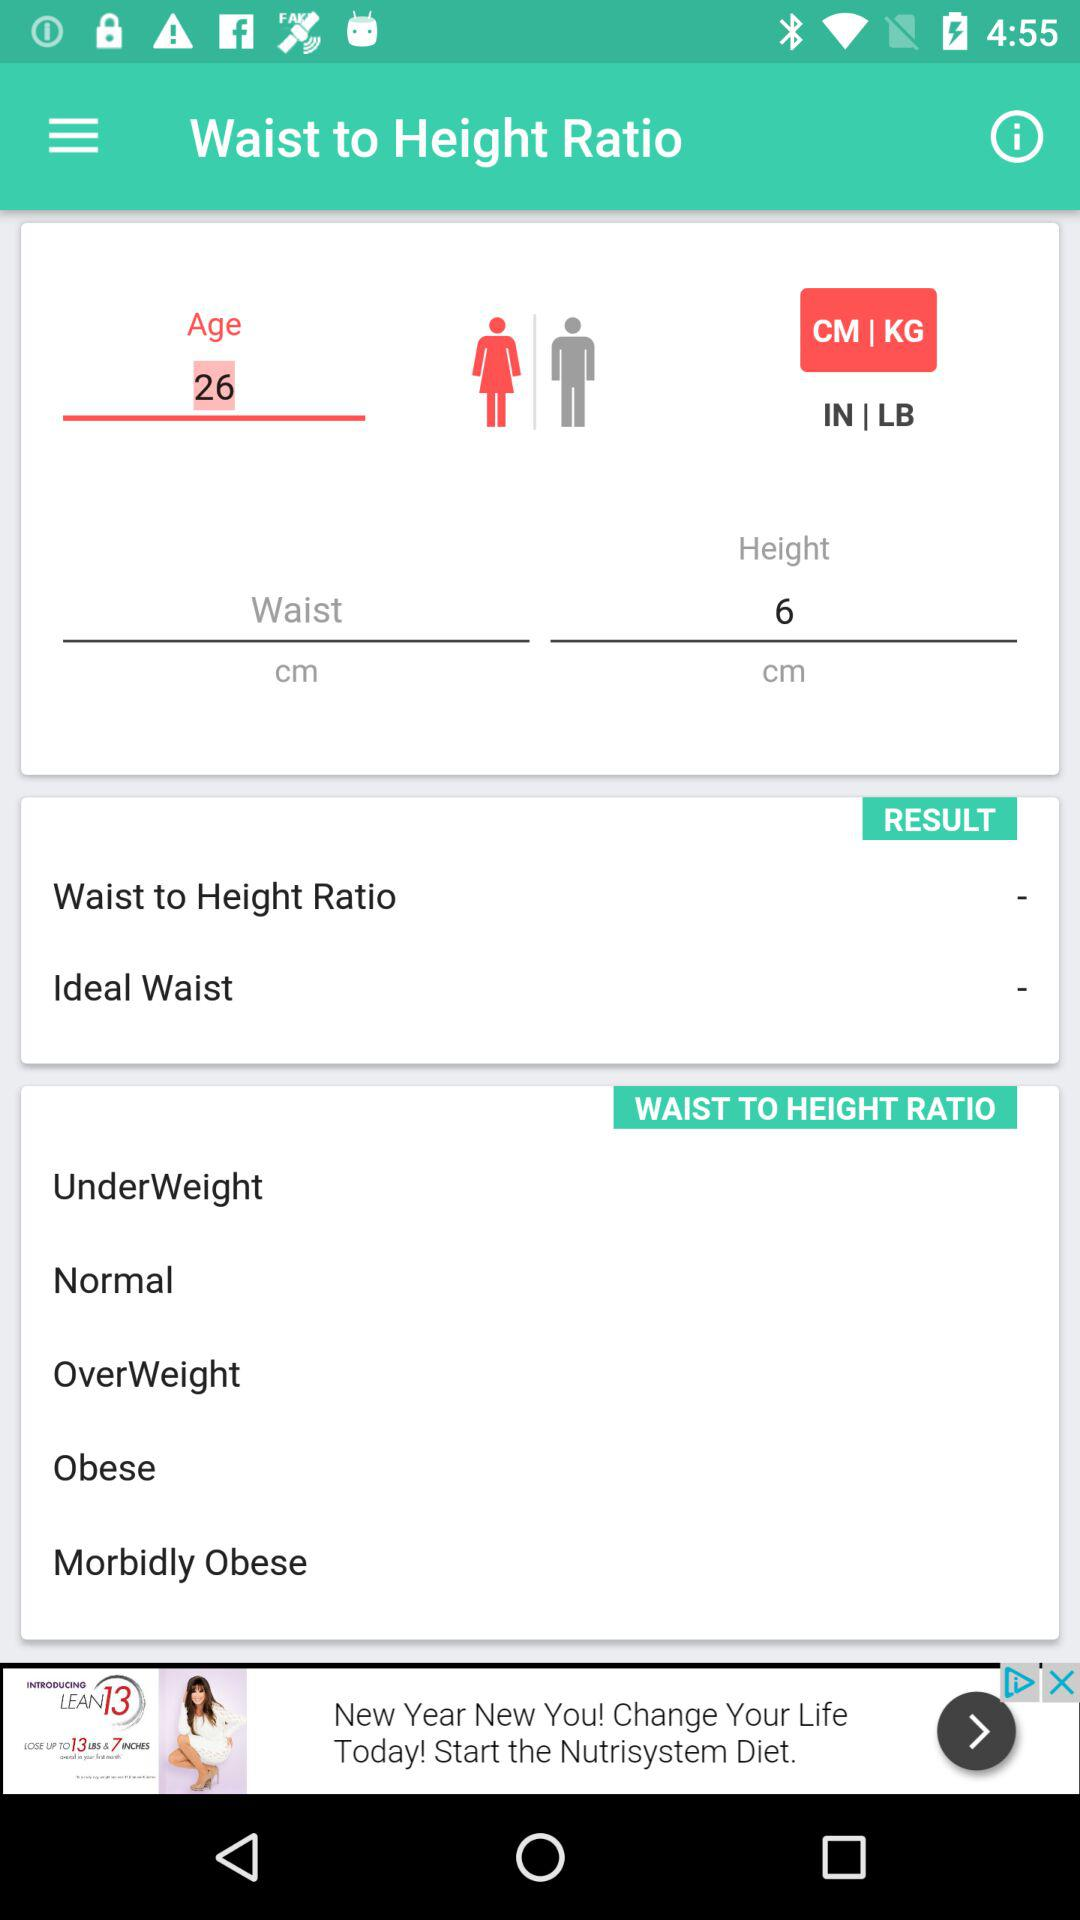What is the age entered on the screen? The age entered on the screen is 26. 